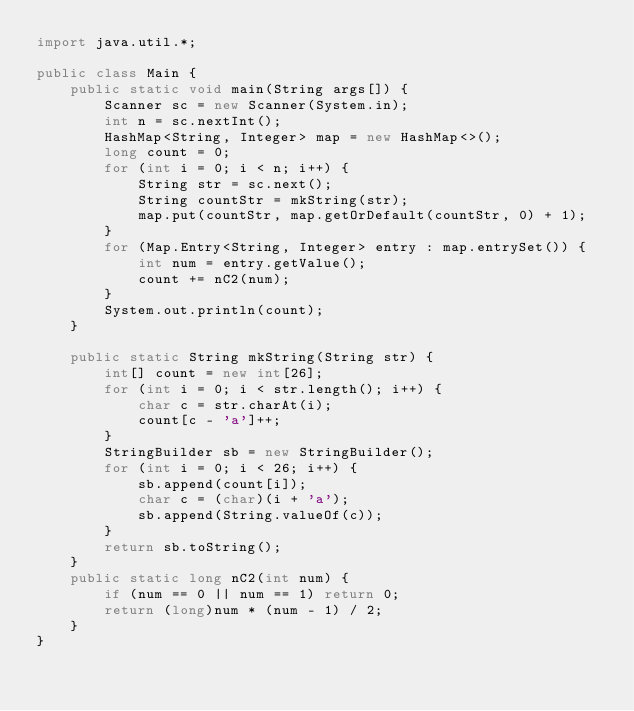<code> <loc_0><loc_0><loc_500><loc_500><_Java_>import java.util.*;

public class Main {
    public static void main(String args[]) {
        Scanner sc = new Scanner(System.in);
        int n = sc.nextInt();
        HashMap<String, Integer> map = new HashMap<>();
        long count = 0;
        for (int i = 0; i < n; i++) {
            String str = sc.next();
            String countStr = mkString(str);
            map.put(countStr, map.getOrDefault(countStr, 0) + 1);
        }
        for (Map.Entry<String, Integer> entry : map.entrySet()) {
            int num = entry.getValue();
            count += nC2(num);
        }
        System.out.println(count);
    }

    public static String mkString(String str) {
        int[] count = new int[26];
        for (int i = 0; i < str.length(); i++) {
            char c = str.charAt(i);
            count[c - 'a']++;
        }
        StringBuilder sb = new StringBuilder();
        for (int i = 0; i < 26; i++) {
            sb.append(count[i]);
            char c = (char)(i + 'a');
            sb.append(String.valueOf(c));
        }
        return sb.toString();
    }
    public static long nC2(int num) {
        if (num == 0 || num == 1) return 0;
        return (long)num * (num - 1) / 2;
    }
}
</code> 